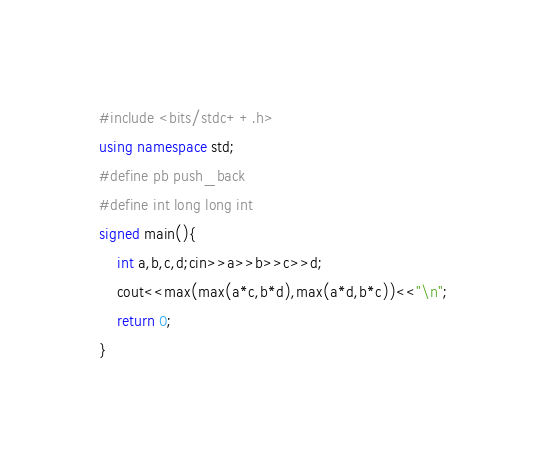<code> <loc_0><loc_0><loc_500><loc_500><_C++_>#include <bits/stdc++.h>
using namespace std;
#define pb push_back
#define int long long int
signed main(){
    int a,b,c,d;cin>>a>>b>>c>>d;
    cout<<max(max(a*c,b*d),max(a*d,b*c))<<"\n";
    return 0;
}
</code> 